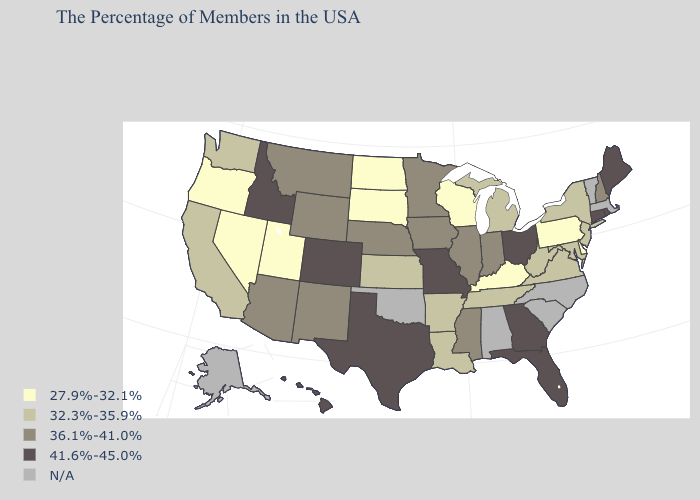Name the states that have a value in the range 36.1%-41.0%?
Answer briefly. New Hampshire, Indiana, Illinois, Mississippi, Minnesota, Iowa, Nebraska, Wyoming, New Mexico, Montana, Arizona. What is the value of Alabama?
Keep it brief. N/A. Is the legend a continuous bar?
Be succinct. No. Does the first symbol in the legend represent the smallest category?
Quick response, please. Yes. What is the value of North Carolina?
Answer briefly. N/A. What is the highest value in the USA?
Keep it brief. 41.6%-45.0%. What is the highest value in states that border Colorado?
Keep it brief. 36.1%-41.0%. What is the lowest value in the USA?
Write a very short answer. 27.9%-32.1%. What is the lowest value in the USA?
Keep it brief. 27.9%-32.1%. Does South Dakota have the lowest value in the MidWest?
Concise answer only. Yes. Which states hav the highest value in the Northeast?
Short answer required. Maine, Rhode Island, Connecticut. How many symbols are there in the legend?
Answer briefly. 5. How many symbols are there in the legend?
Short answer required. 5. 